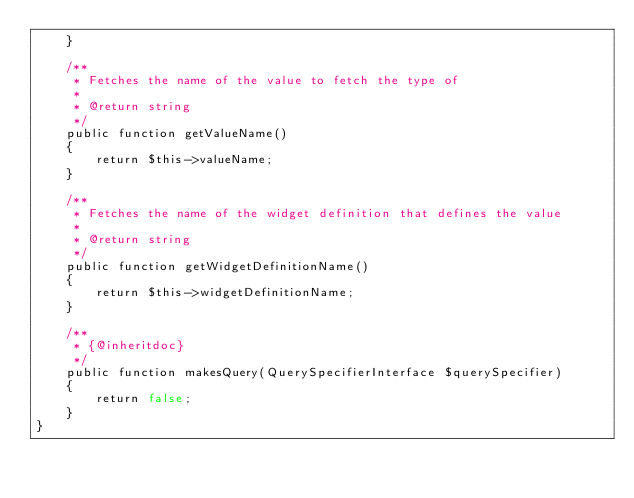Convert code to text. <code><loc_0><loc_0><loc_500><loc_500><_PHP_>    }

    /**
     * Fetches the name of the value to fetch the type of
     *
     * @return string
     */
    public function getValueName()
    {
        return $this->valueName;
    }

    /**
     * Fetches the name of the widget definition that defines the value
     *
     * @return string
     */
    public function getWidgetDefinitionName()
    {
        return $this->widgetDefinitionName;
    }

    /**
     * {@inheritdoc}
     */
    public function makesQuery(QuerySpecifierInterface $querySpecifier)
    {
        return false;
    }
}
</code> 